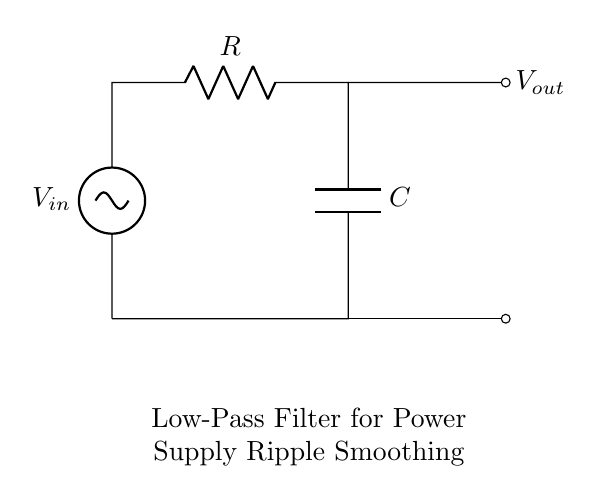What is the input voltage for this circuit? The input voltage is labeled as V_in in the circuit diagram. It represents the voltage supplied to the circuit.
Answer: V_in What components are used in the circuit? The components in the circuit are a resistor identified as R and a capacitor labeled as C. These components are connected in a specific manner to create the low-pass filter.
Answer: Resistor and Capacitor How many output connections does this circuit have? There are two output connections; one is at the top labeled V_out and the other is at the bottom where the capacitor connects.
Answer: Two What is the primary function of this low-pass filter? The primary function is to smooth out power supply ripples, allowing only low-frequency signals to pass while attenuating higher frequencies.
Answer: Smoothing ripples If the resistor value is doubled, how does it affect the cutoff frequency? Doubling the resistor value lowers the cutoff frequency, making the filter more effective at passing low frequencies while blocking high frequencies based on the RC time constant formula.
Answer: Lowers cutoff frequency What happens to the output voltage when the frequency increases? As the frequency increases, the output voltage decreases due to the filter's design, which is meant to attenuate higher frequency signals while allowing lower frequencies to pass through.
Answer: Decreases 